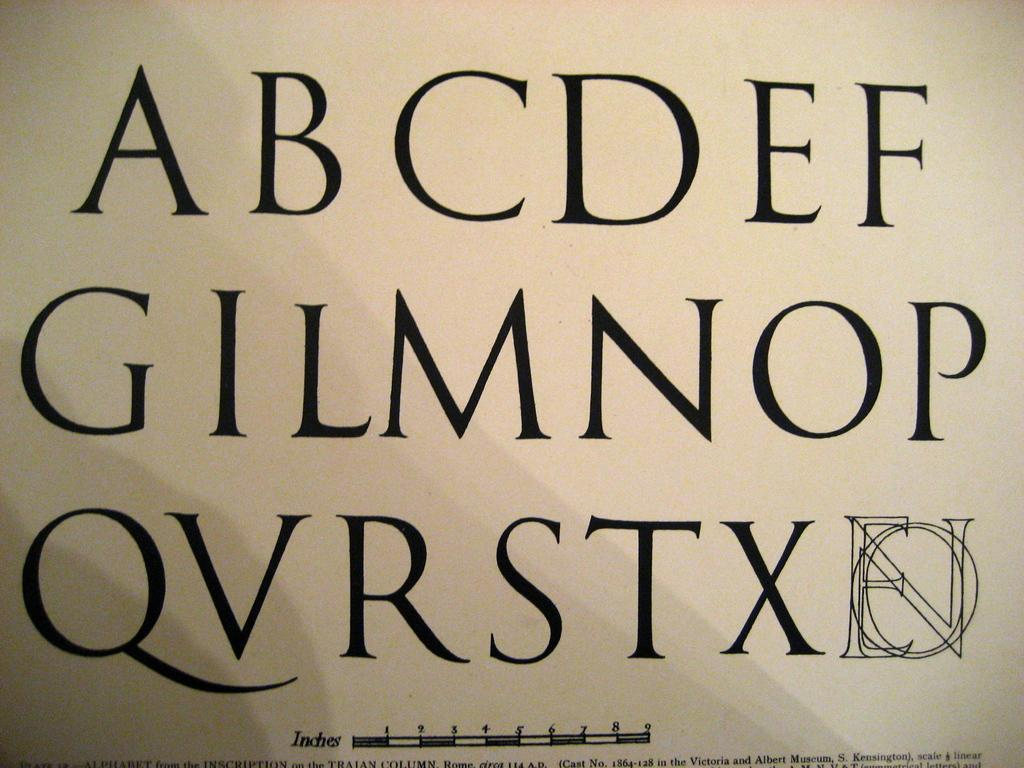<image>
Summarize the visual content of the image. An Alphabet chart is missing some letters such as H, J, and K and other letters are out of order. 